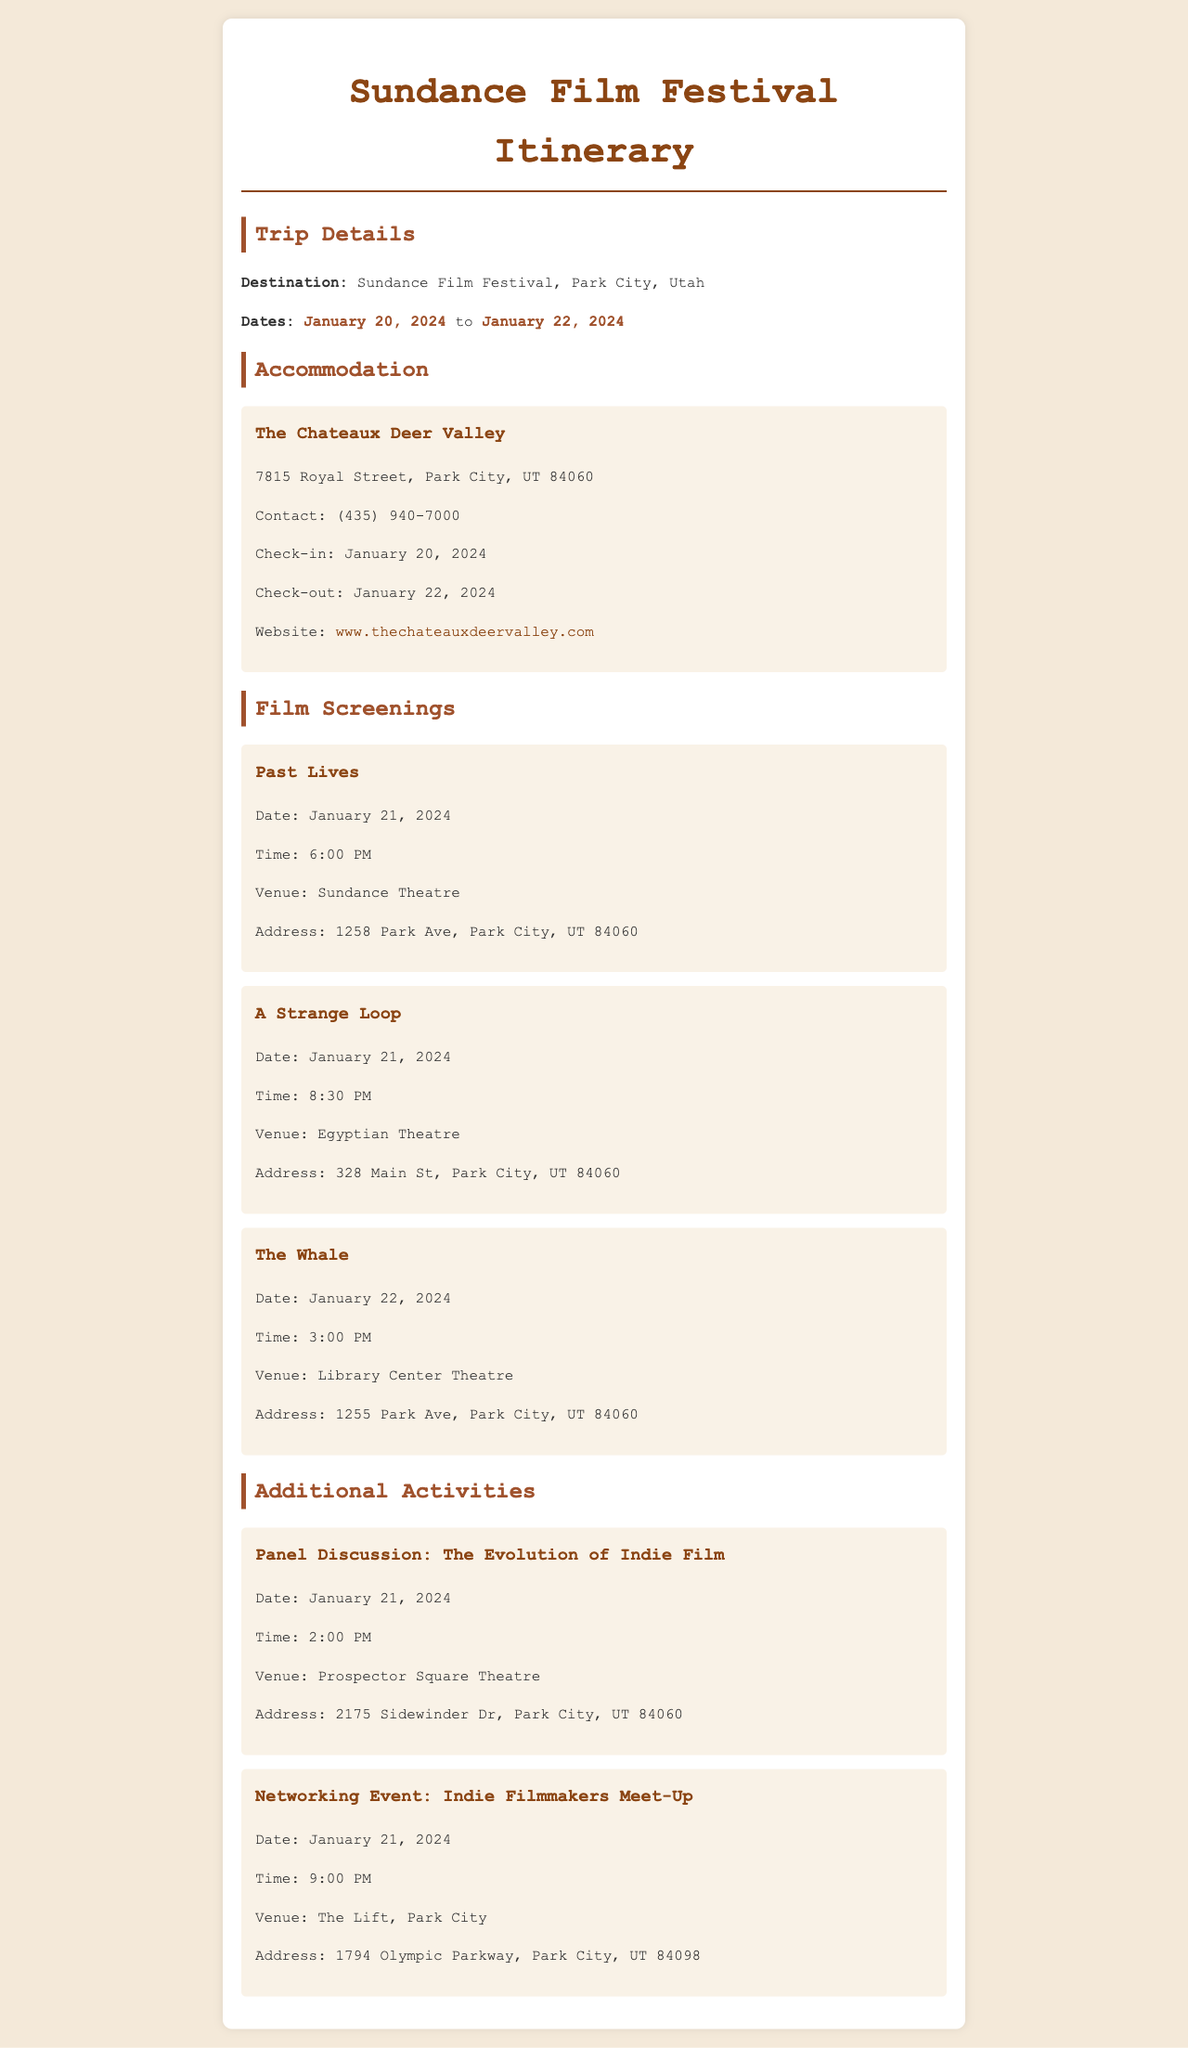What are the travel dates? The travel dates are specified in the document as January 20, 2024 to January 22, 2024.
Answer: January 20, 2024 to January 22, 2024 What is the address of The Chateaux Deer Valley? The address of the accommodation is provided in the document as 7815 Royal Street, Park City, UT 84060.
Answer: 7815 Royal Street, Park City, UT 84060 What time does the screening of "Past Lives" begin? The time for the screening of "Past Lives" is mentioned as 6:00 PM in the document.
Answer: 6:00 PM Which film is screened at the Egyptian Theatre? The document states that "A Strange Loop" is scheduled to be screened at the Egyptian Theatre.
Answer: A Strange Loop What is the venue for the panel discussion? The venue for the panel discussion is given as Prospector Square Theatre in the document.
Answer: Prospector Square Theatre How many films are screened on January 21, 2024? The document lists two films scheduled for screening on January 21, 2024, which are "Past Lives" and "A Strange Loop."
Answer: Two What is the contact number for The Chateaux Deer Valley? The contact number is provided in the document as (435) 940-7000.
Answer: (435) 940-7000 When does the Networking Event take place? The Networking Event takes place on January 21, 2024, at 9:00 PM according to the document.
Answer: January 21, 2024, at 9:00 PM What is the address of the Library Center Theatre? The document states the address of Library Center Theatre as 1255 Park Ave, Park City, UT 84060.
Answer: 1255 Park Ave, Park City, UT 84060 